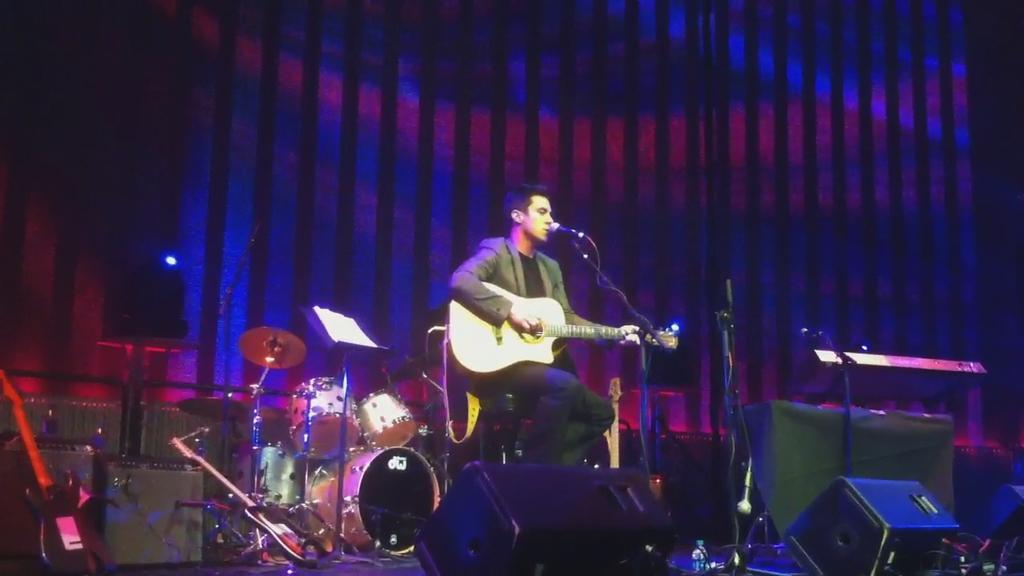Who is present in the image? There is a person in the image. What is the person doing in the image? The person is sitting in the image. What object is the person holding in the image? The person is holding a guitar in his hand. What can be seen in the background of the image? There is a drum set in the background of the image. How many ducks are visible in the image? There are no ducks present in the image. What type of hall is the person performing in? The image does not provide information about a hall or a performance; it simply shows a person sitting with a guitar and a drum set in the background. 